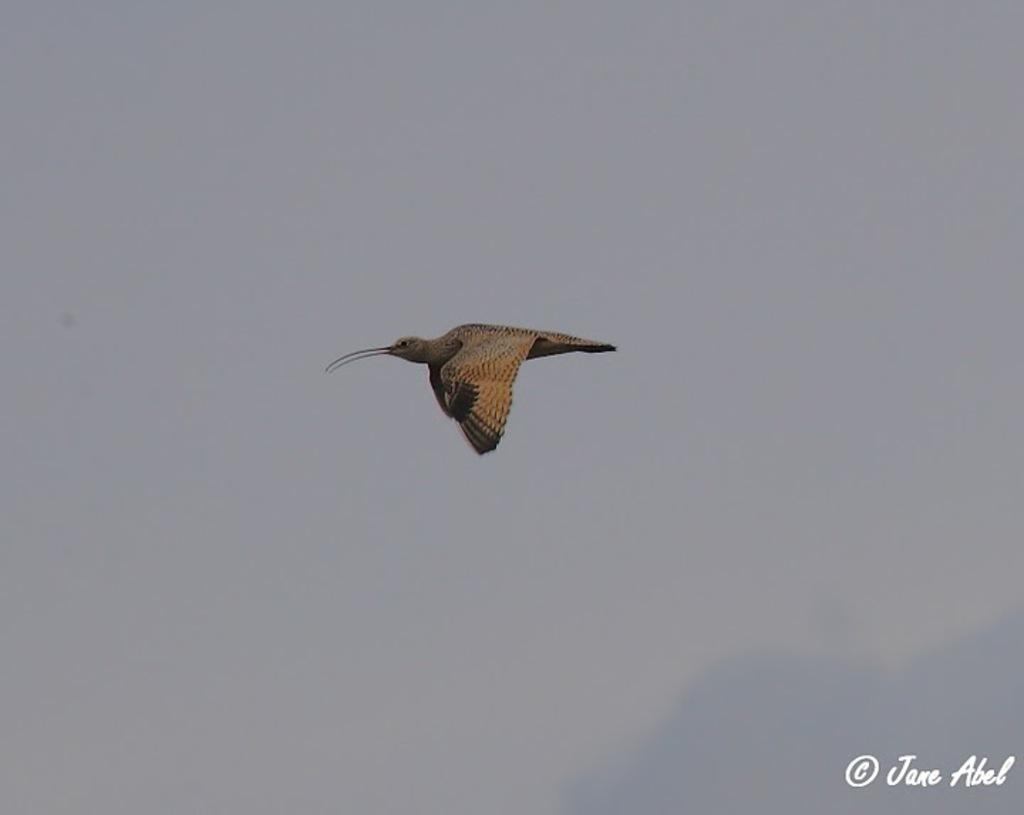What is happening in the sky in the image? There is a bird flying in the sky in the image. Is there any text present in the image? Yes, there is text visible in the bottom right corner of the image. What type of lettuce is being used to hold the attention of the bird in the image? There is no lettuce or any indication of the bird's attention being held in the image. 